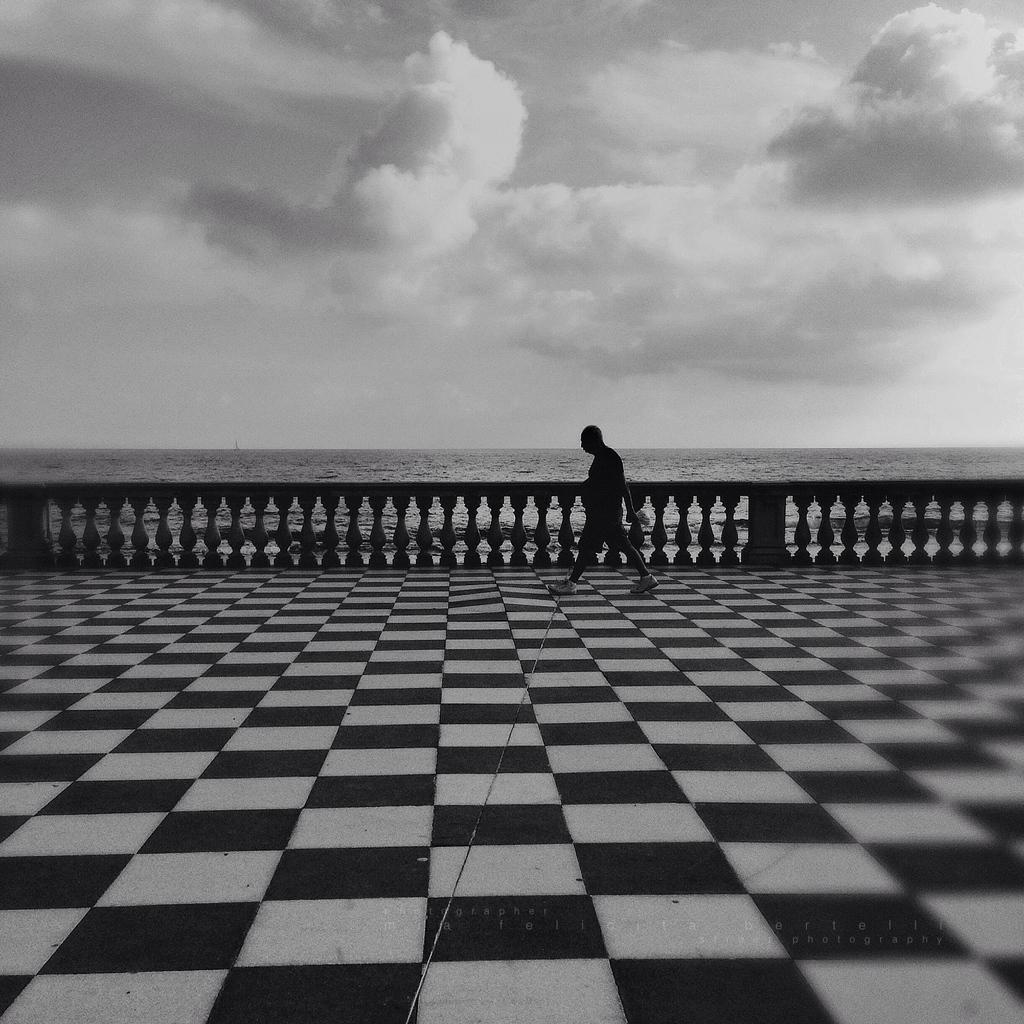How would you summarize this image in a sentence or two? This picture is clicked outside. In the center there is a person walking on the ground. In the background we can see the sky which is full of clouds. 